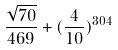Convert formula to latex. <formula><loc_0><loc_0><loc_500><loc_500>\frac { \sqrt { 7 0 } } { 4 6 9 } + ( \frac { 4 } { 1 0 } ) ^ { 3 0 4 }</formula> 